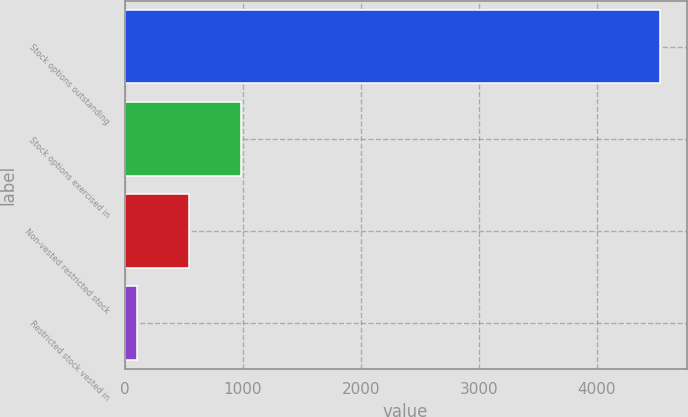<chart> <loc_0><loc_0><loc_500><loc_500><bar_chart><fcel>Stock options outstanding<fcel>Stock options exercised in<fcel>Non-vested restricted stock<fcel>Restricted stock vested in<nl><fcel>4534<fcel>988.4<fcel>545.2<fcel>102<nl></chart> 